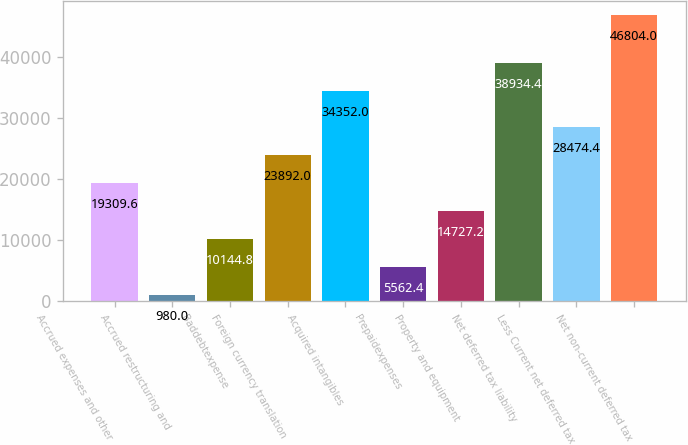Convert chart to OTSL. <chart><loc_0><loc_0><loc_500><loc_500><bar_chart><fcel>Accrued expenses and other<fcel>Accrued restructuring and<fcel>Baddebtexpense<fcel>Foreign currency translation<fcel>Acquired intangibles<fcel>Prepaidexpenses<fcel>Property and equipment<fcel>Net deferred tax liability<fcel>Less Current net deferred tax<fcel>Net non-current deferred tax<nl><fcel>19309.6<fcel>980<fcel>10144.8<fcel>23892<fcel>34352<fcel>5562.4<fcel>14727.2<fcel>38934.4<fcel>28474.4<fcel>46804<nl></chart> 